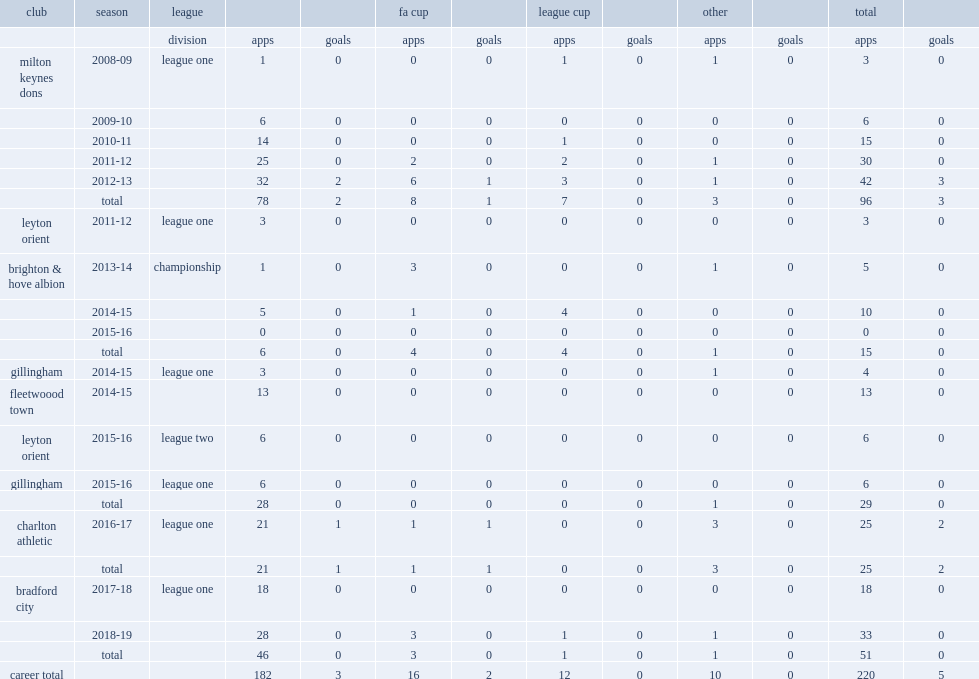Which club did adam chicksen play for in 2012-13? Milton keynes dons. 